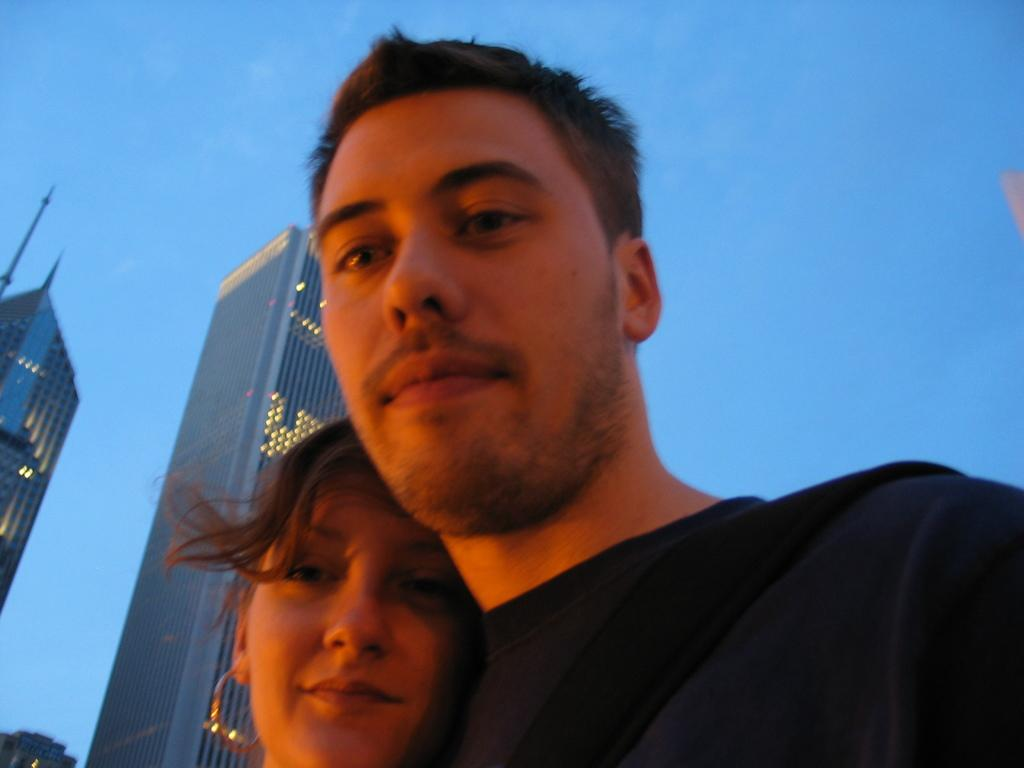Who is present in the image? There is a man and a woman in the image. What expressions do the man and woman have? Both the man and woman are smiling in the image. What can be seen in the background of the image? Buildings, lights, and the sky are visible in the background of the image. What type of wax is being used by the man in the image? There is no wax present in the image, and the man is not using any wax. How many cars can be seen in the image? There are no cars visible in the image. 